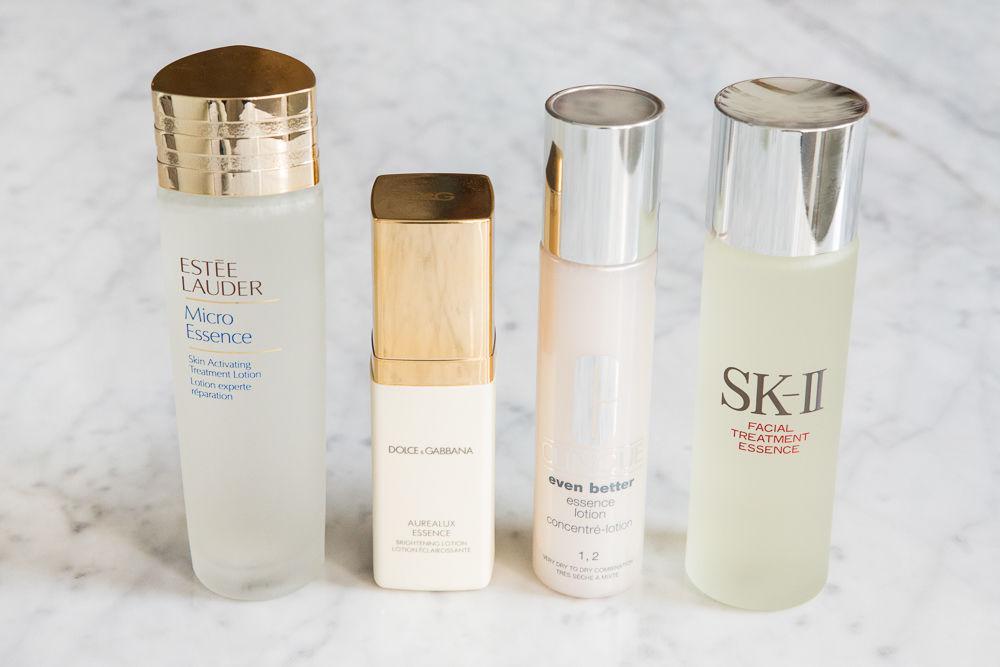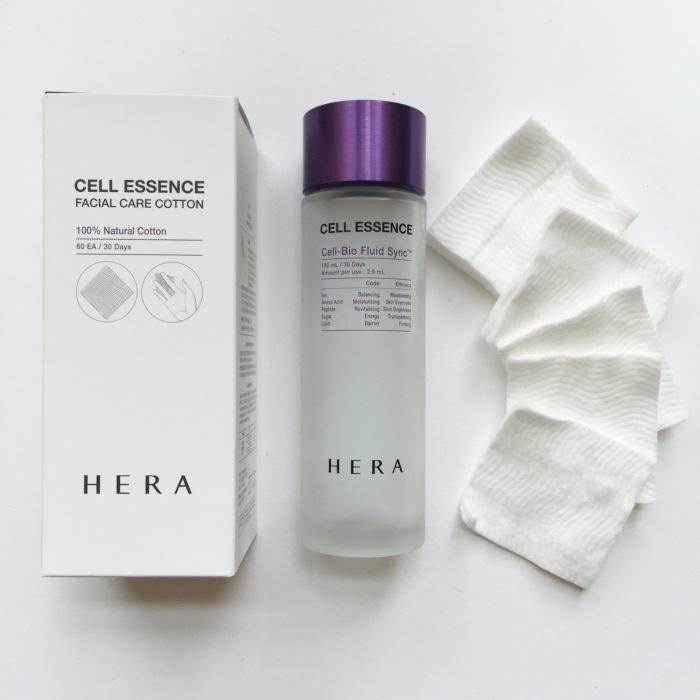The first image is the image on the left, the second image is the image on the right. Considering the images on both sides, is "Four or more skin products are standing upright on a counter in the left photo." valid? Answer yes or no. Yes. The first image is the image on the left, the second image is the image on the right. Examine the images to the left and right. Is the description "An image shows exactly one skincare product, which has a gold cap." accurate? Answer yes or no. No. 